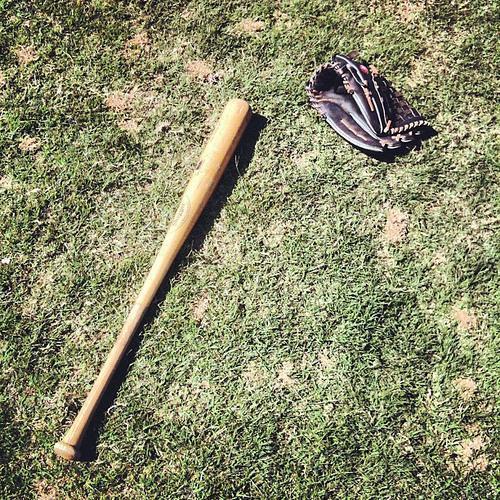How many items are in the picture?
Give a very brief answer. 2. How many objects?
Give a very brief answer. 2. 